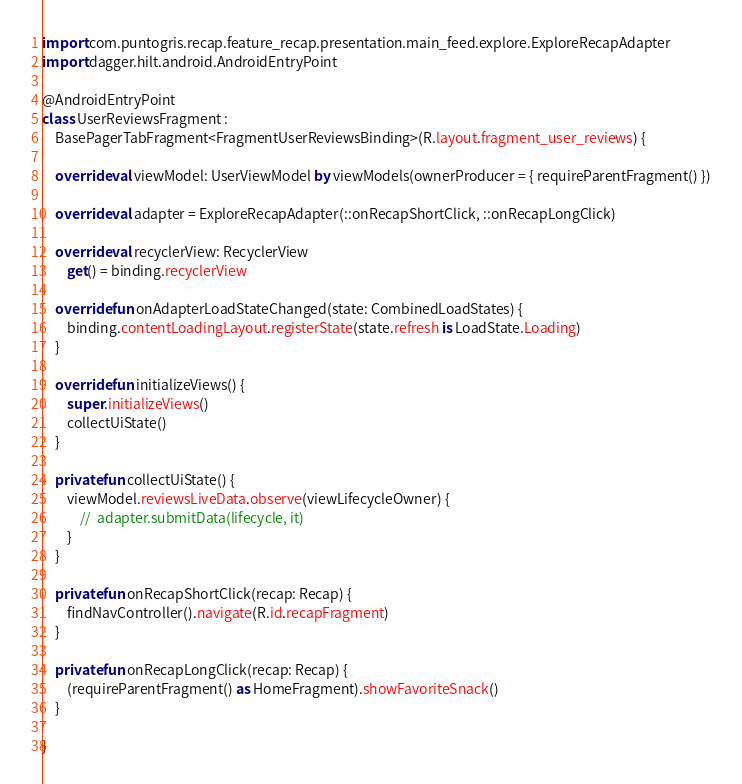Convert code to text. <code><loc_0><loc_0><loc_500><loc_500><_Kotlin_>import com.puntogris.recap.feature_recap.presentation.main_feed.explore.ExploreRecapAdapter
import dagger.hilt.android.AndroidEntryPoint

@AndroidEntryPoint
class UserReviewsFragment :
    BasePagerTabFragment<FragmentUserReviewsBinding>(R.layout.fragment_user_reviews) {

    override val viewModel: UserViewModel by viewModels(ownerProducer = { requireParentFragment() })

    override val adapter = ExploreRecapAdapter(::onRecapShortClick, ::onRecapLongClick)

    override val recyclerView: RecyclerView
        get() = binding.recyclerView

    override fun onAdapterLoadStateChanged(state: CombinedLoadStates) {
        binding.contentLoadingLayout.registerState(state.refresh is LoadState.Loading)
    }

    override fun initializeViews() {
        super.initializeViews()
        collectUiState()
    }

    private fun collectUiState() {
        viewModel.reviewsLiveData.observe(viewLifecycleOwner) {
            //  adapter.submitData(lifecycle, it)
        }
    }

    private fun onRecapShortClick(recap: Recap) {
        findNavController().navigate(R.id.recapFragment)
    }

    private fun onRecapLongClick(recap: Recap) {
        (requireParentFragment() as HomeFragment).showFavoriteSnack()
    }

}</code> 